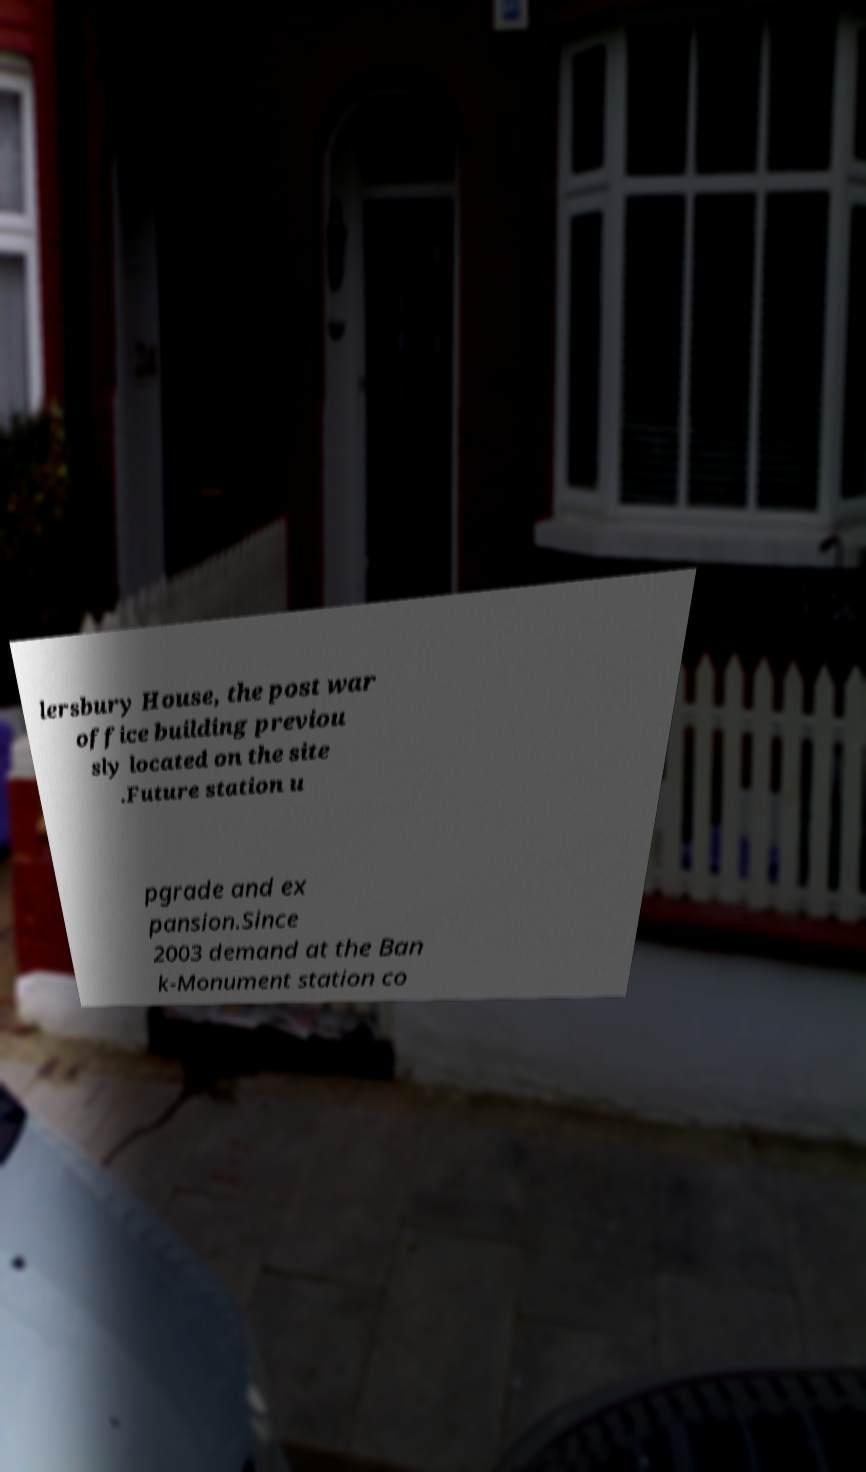Could you assist in decoding the text presented in this image and type it out clearly? lersbury House, the post war office building previou sly located on the site .Future station u pgrade and ex pansion.Since 2003 demand at the Ban k-Monument station co 